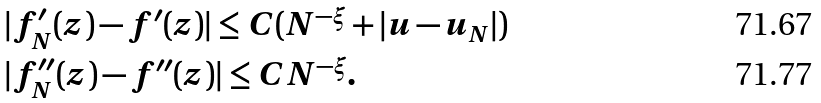Convert formula to latex. <formula><loc_0><loc_0><loc_500><loc_500>& | f _ { N } ^ { \prime } ( z ) - f ^ { \prime } ( z ) | \leq C ( N ^ { - \xi } + | u - u _ { N } | ) \\ & | f _ { N } ^ { \prime \prime } ( z ) - f ^ { \prime \prime } ( z ) | \leq C N ^ { - \xi } .</formula> 